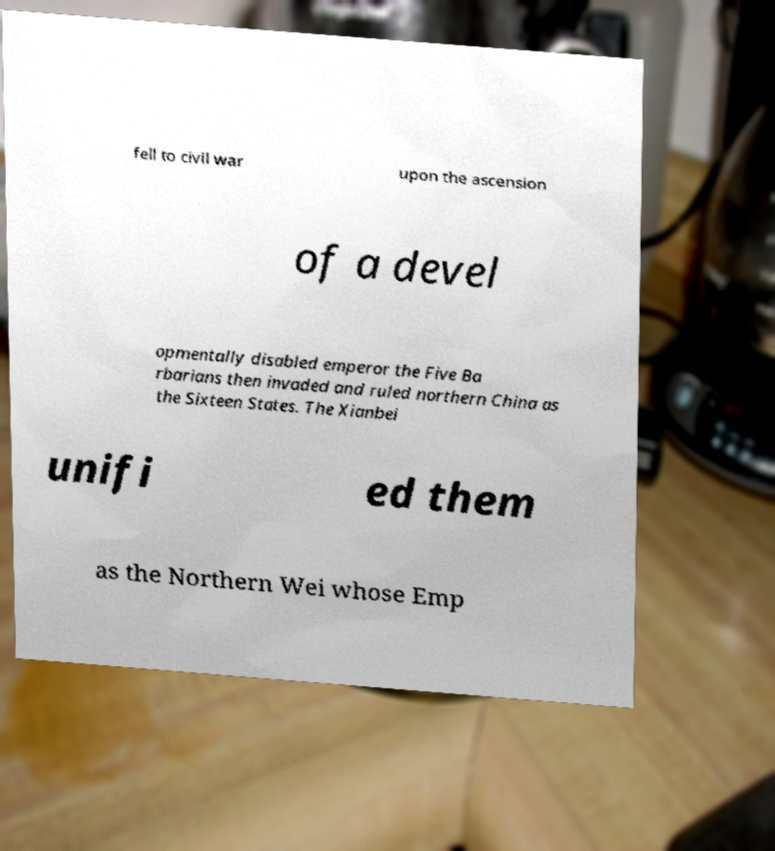Please read and relay the text visible in this image. What does it say? fell to civil war upon the ascension of a devel opmentally disabled emperor the Five Ba rbarians then invaded and ruled northern China as the Sixteen States. The Xianbei unifi ed them as the Northern Wei whose Emp 